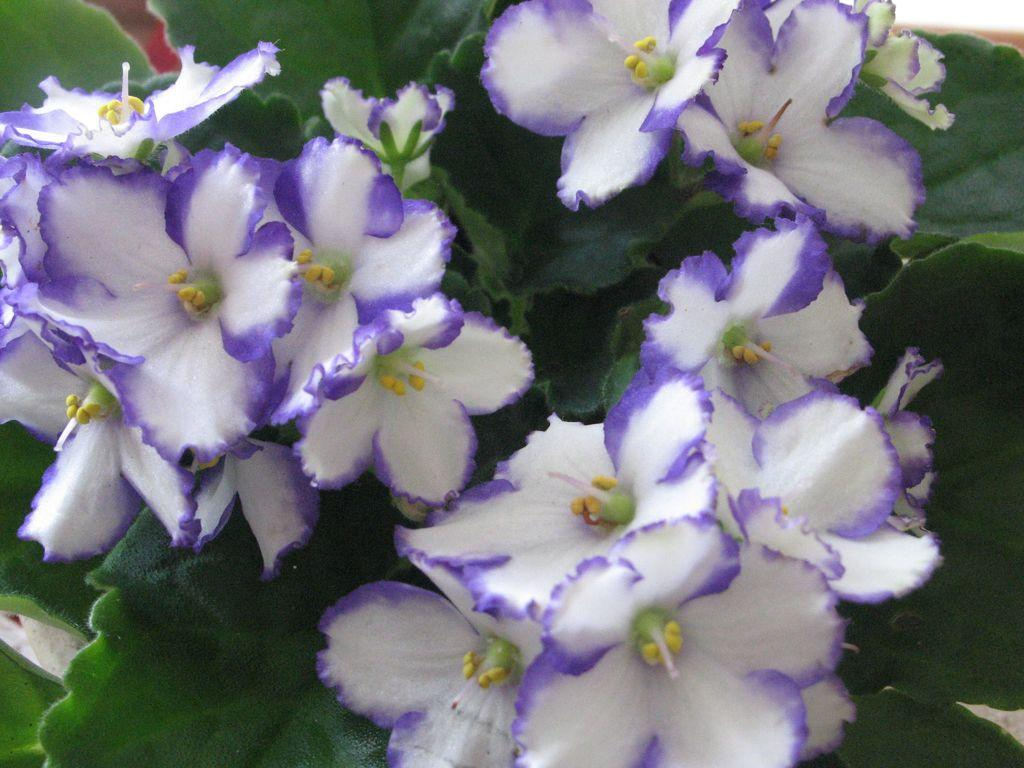What type of plant life is visible in the image? There are flowers and leaves in the image. Can you describe the flowers in the image? Unfortunately, the facts provided do not give specific details about the flowers. What is the relationship between the flowers and leaves in the image? The flowers and leaves are likely part of the same plant or plants, but the facts provided do not give specific details about their arrangement or relationship. What type of pancake is being served for approval at the time depicted in the image? There is no pancake or indication of approval or time in the image; it only features flowers and leaves. 